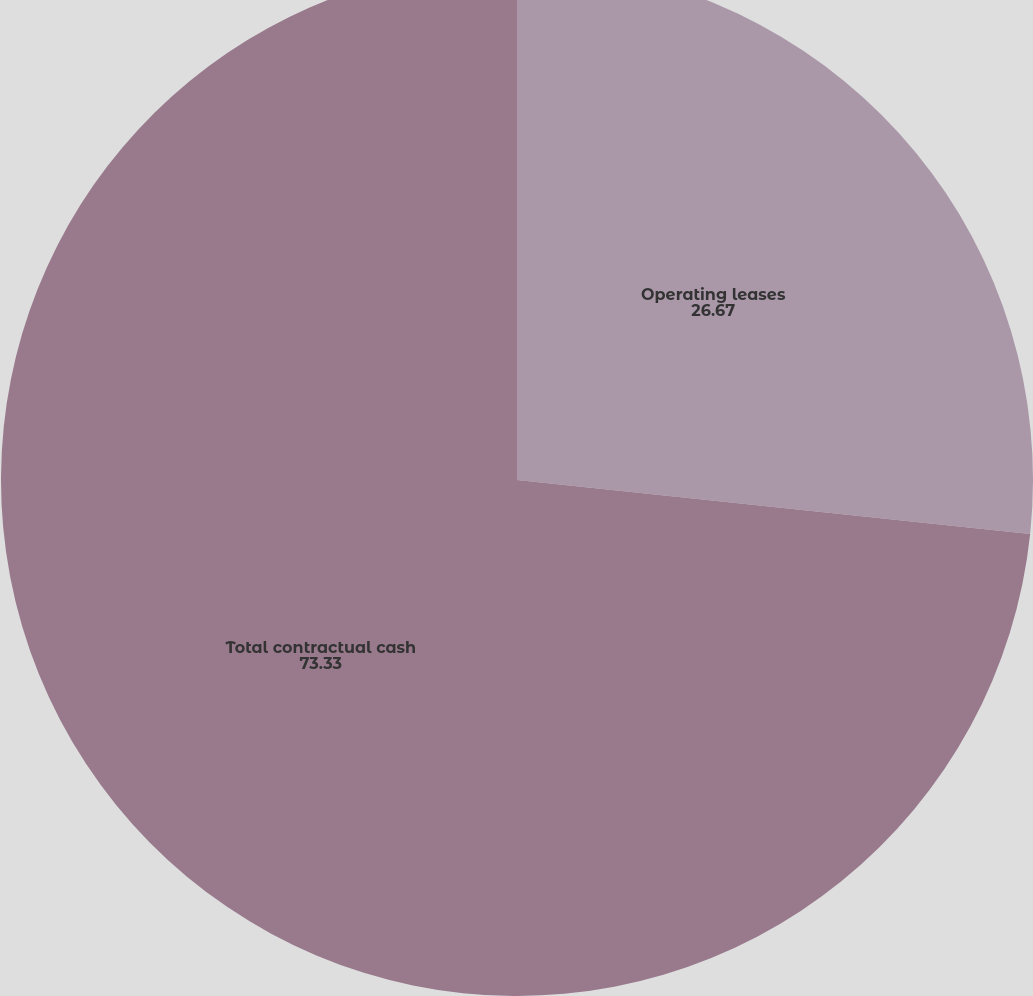<chart> <loc_0><loc_0><loc_500><loc_500><pie_chart><fcel>Operating leases<fcel>Total contractual cash<nl><fcel>26.67%<fcel>73.33%<nl></chart> 